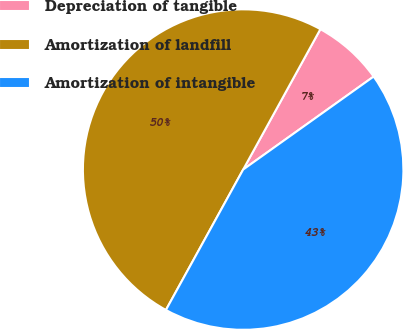Convert chart to OTSL. <chart><loc_0><loc_0><loc_500><loc_500><pie_chart><fcel>Depreciation of tangible<fcel>Amortization of landfill<fcel>Amortization of intangible<nl><fcel>7.14%<fcel>50.0%<fcel>42.86%<nl></chart> 